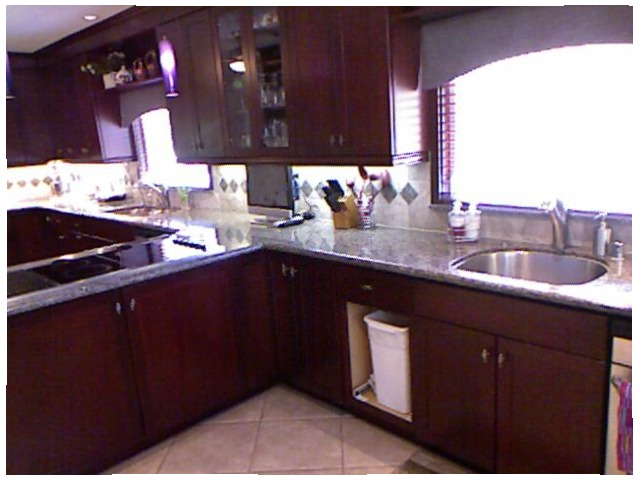<image>
Is the light under the counter? No. The light is not positioned under the counter. The vertical relationship between these objects is different. Is there a garbage can in front of the counter top? No. The garbage can is not in front of the counter top. The spatial positioning shows a different relationship between these objects. Where is the trashcan in relation to the cabinet? Is it in the cabinet? Yes. The trashcan is contained within or inside the cabinet, showing a containment relationship. 